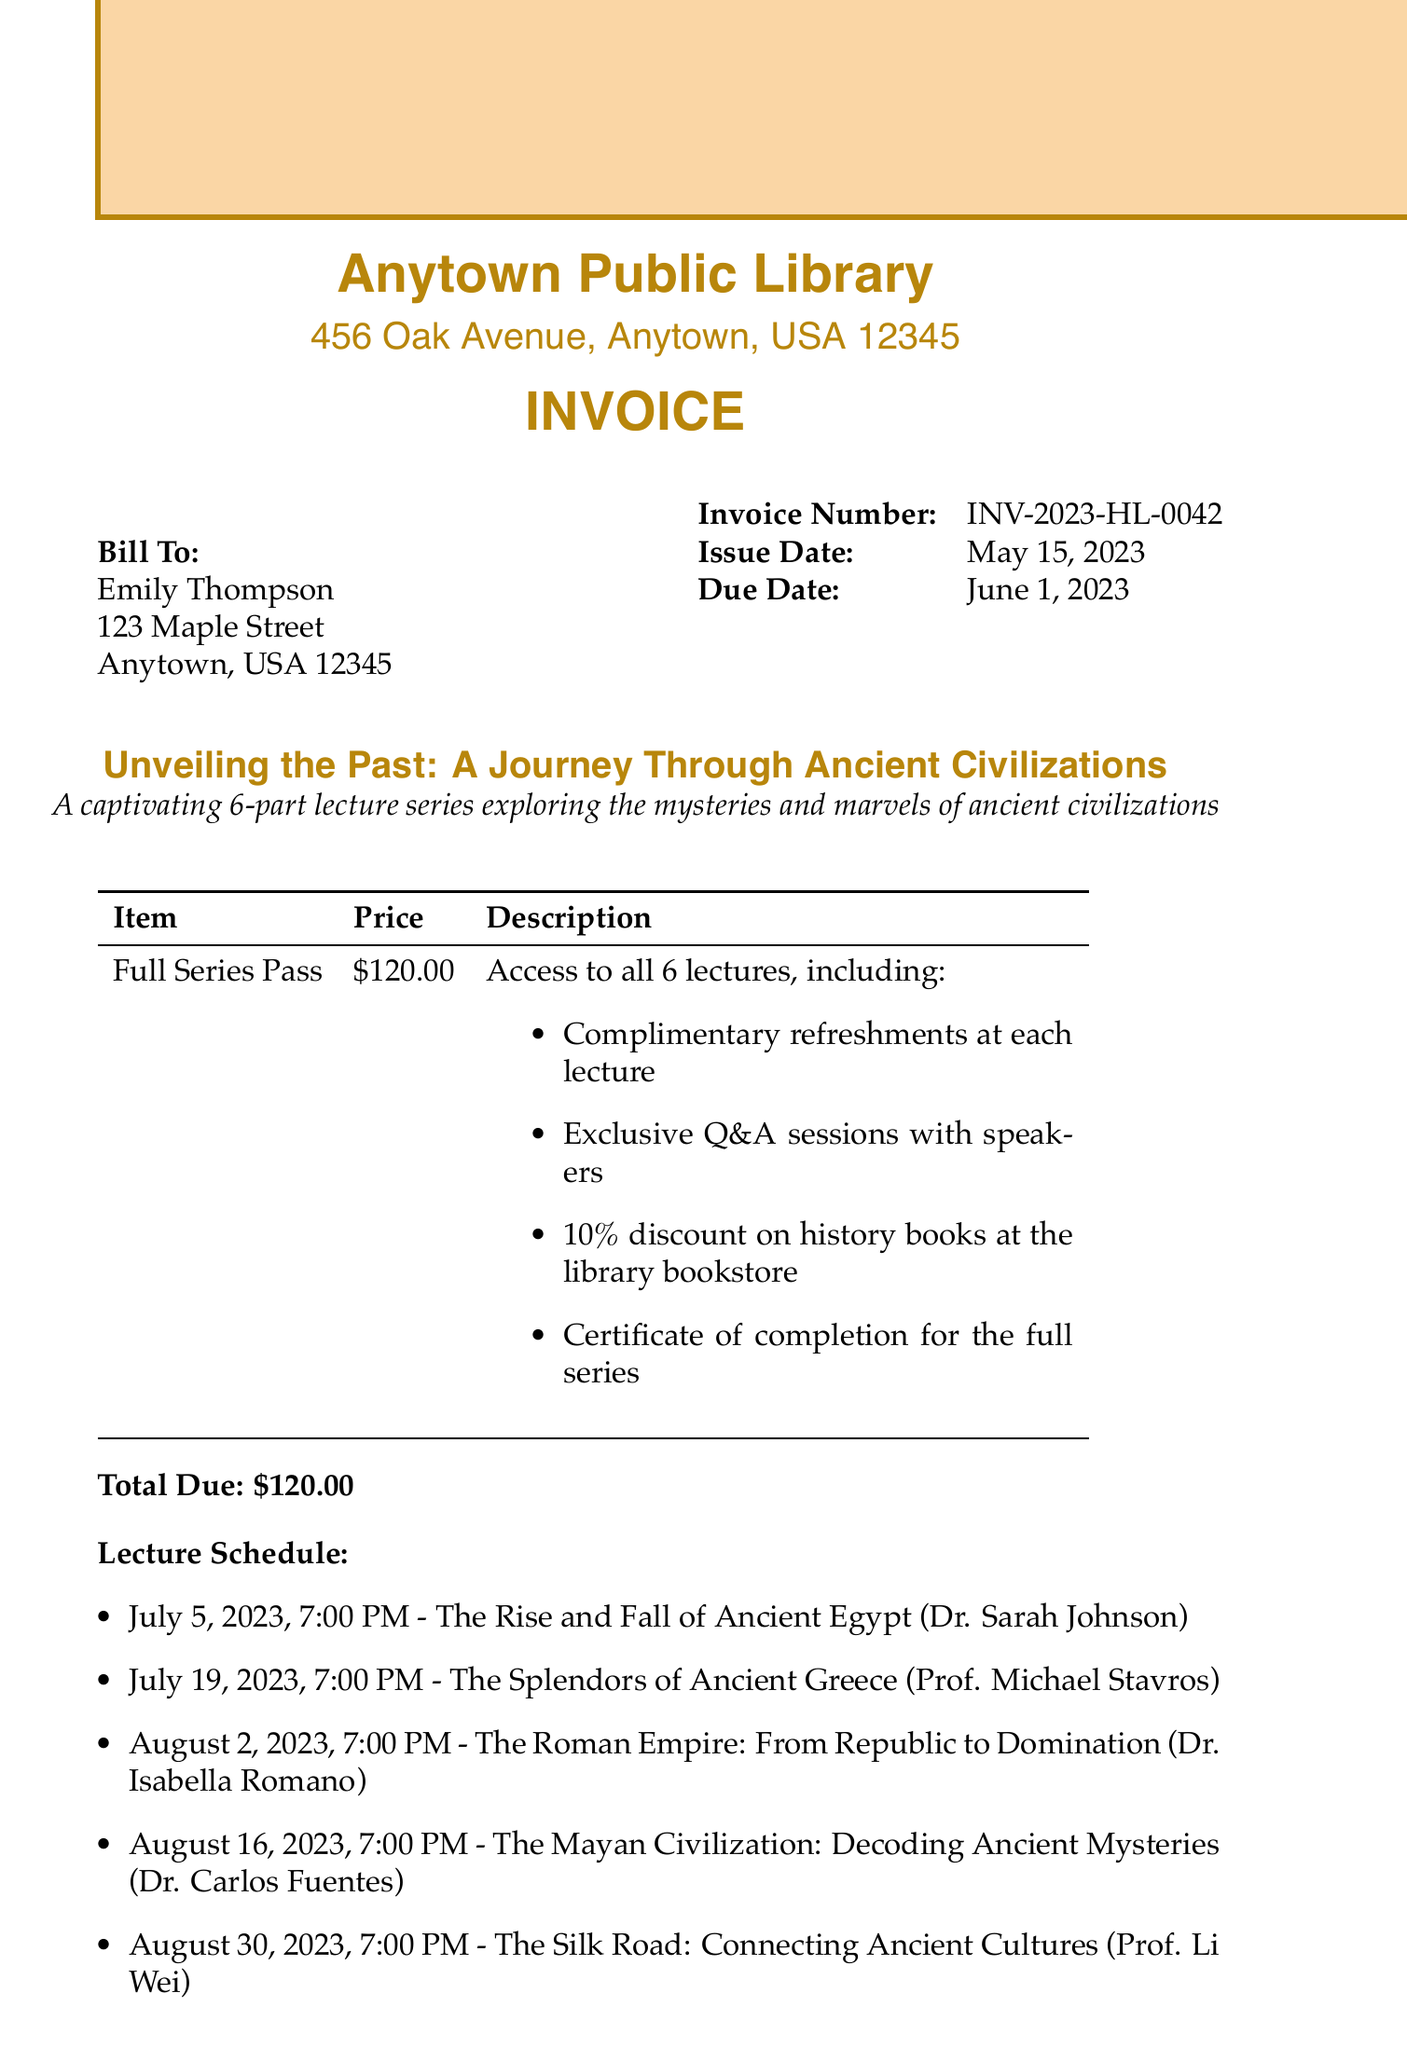What is the invoice number? The invoice number is a unique identifier for this transaction and is listed in the document.
Answer: INV-2023-HL-0042 What is the ticket price for the full series pass? The ticket price can be found in the itemized list on the invoice.
Answer: $120.00 Who is the speaker for the lecture on July 19, 2023? The speaker's name for that date is listed under the specific lecture details.
Answer: Prof. Michael Stavros How many lectures are included in the series? The total number of lectures is mentioned in the event description.
Answer: 6 What is one of the additional benefits included with the ticket package? Additional benefits are listed in the itemized description of the ticket package.
Answer: Complimentary refreshments at each lecture What is the due date for payment? The due date is specified in the invoice details.
Answer: June 1, 2023 What should you do if you have inquiries about the event? The contact information is provided for inquiries about the event.
Answer: Email or phone What does the terms and conditions state about ticket refunds? The terms and conditions provided specify this detail related to ticket refunds.
Answer: Non-refundable but transferable 